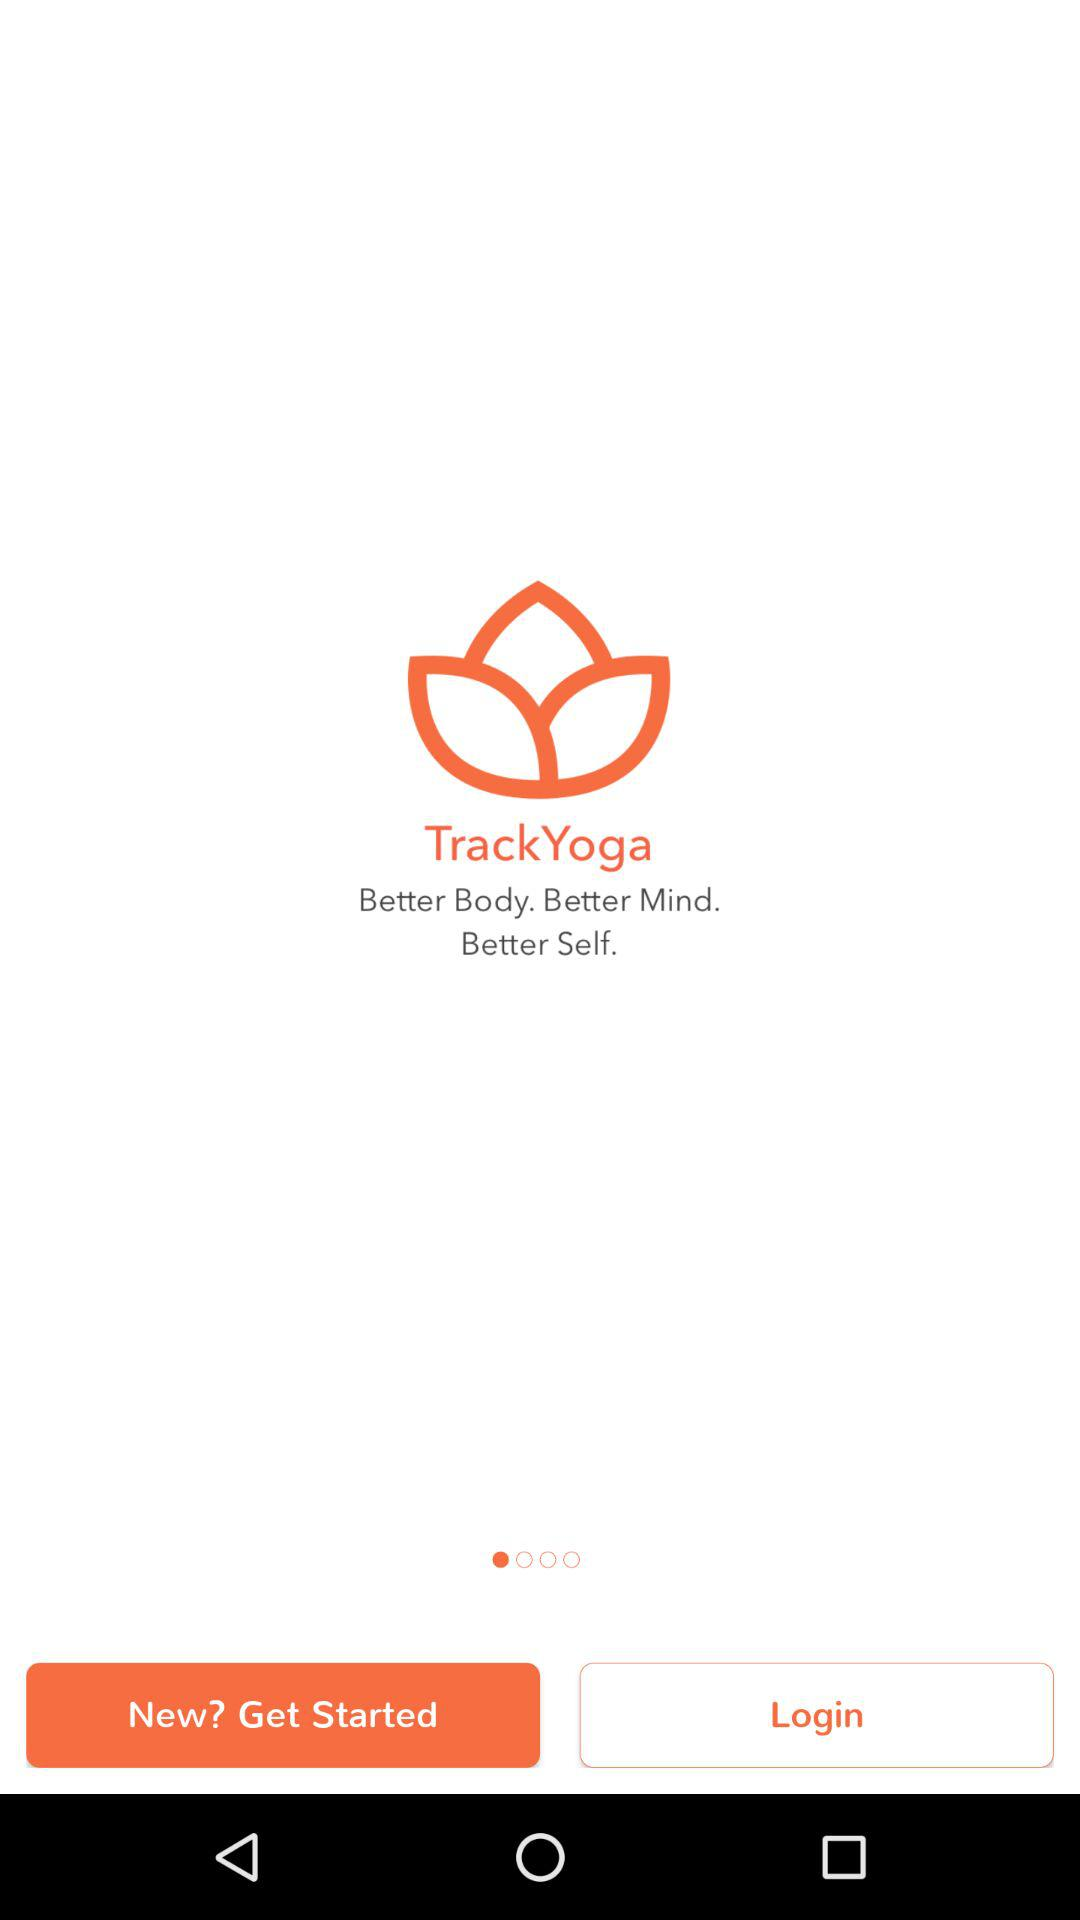What is the application name? The application name is "TrackYoga". 